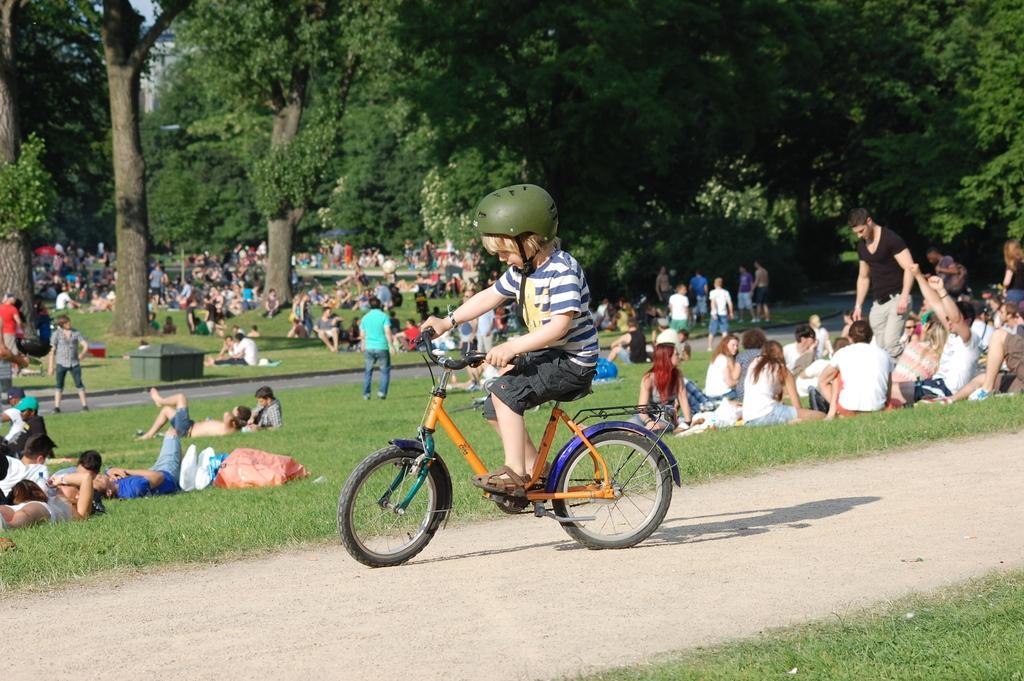Can you describe this image briefly? In the image we can see there is a kid who is sitting on bicycle and he is wearing a green colour helmet and on the ground there are people who are sitting and lying on the ground and few people are standing and there are lot of trees in the area. 